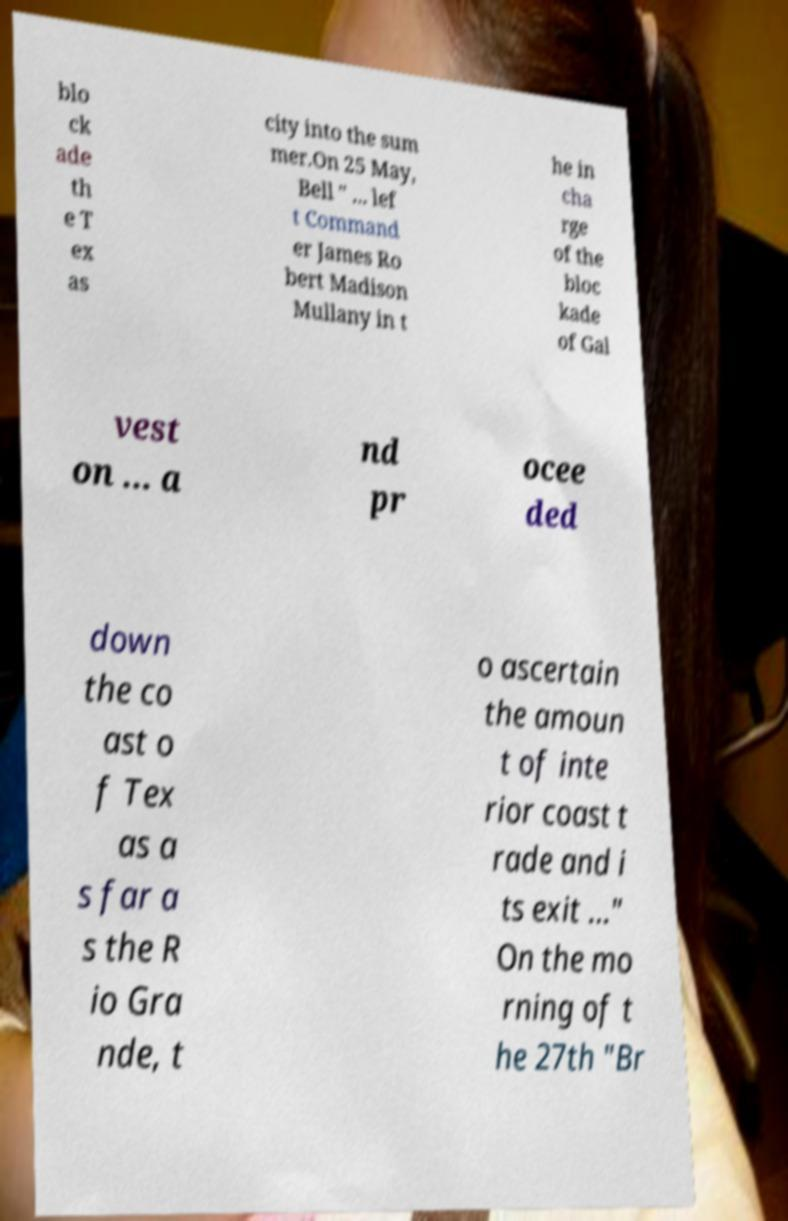Could you assist in decoding the text presented in this image and type it out clearly? blo ck ade th e T ex as city into the sum mer.On 25 May, Bell " ... lef t Command er James Ro bert Madison Mullany in t he in cha rge of the bloc kade of Gal vest on ... a nd pr ocee ded down the co ast o f Tex as a s far a s the R io Gra nde, t o ascertain the amoun t of inte rior coast t rade and i ts exit ..." On the mo rning of t he 27th "Br 